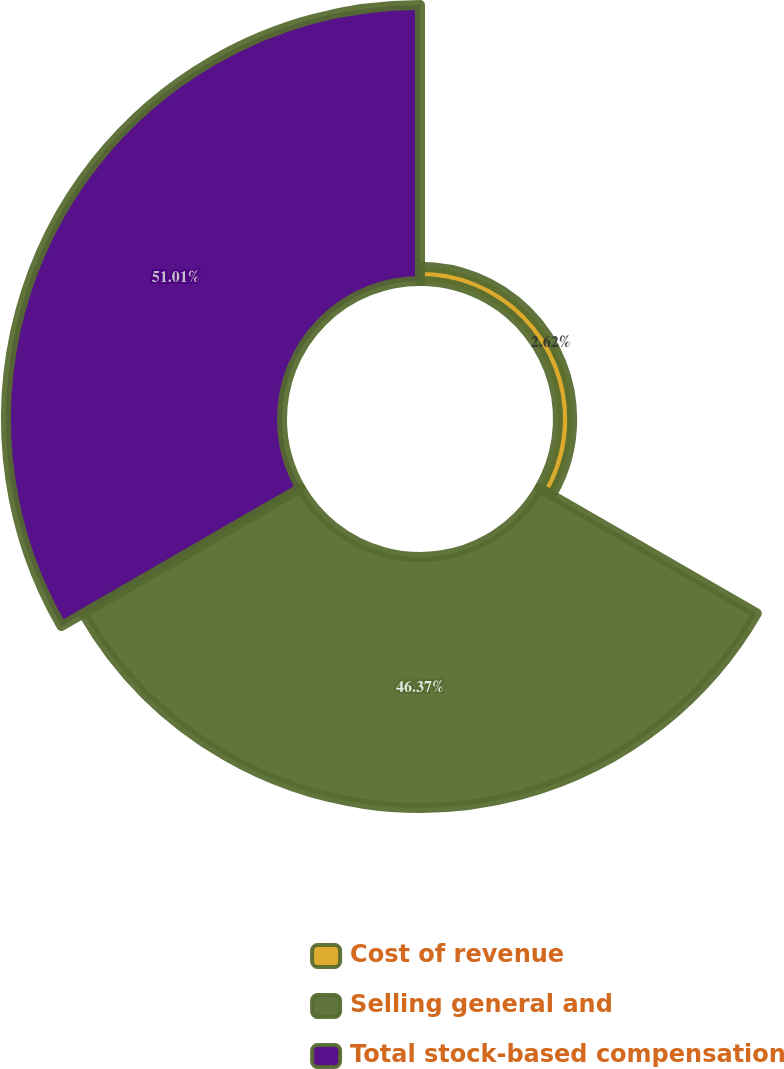Convert chart. <chart><loc_0><loc_0><loc_500><loc_500><pie_chart><fcel>Cost of revenue<fcel>Selling general and<fcel>Total stock-based compensation<nl><fcel>2.62%<fcel>46.37%<fcel>51.01%<nl></chart> 